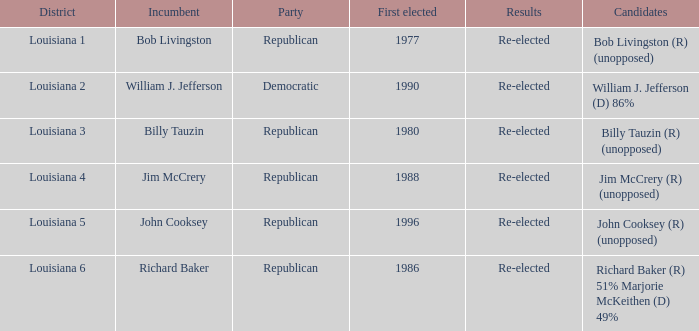To which party does william j. jefferson belong? Democratic. 